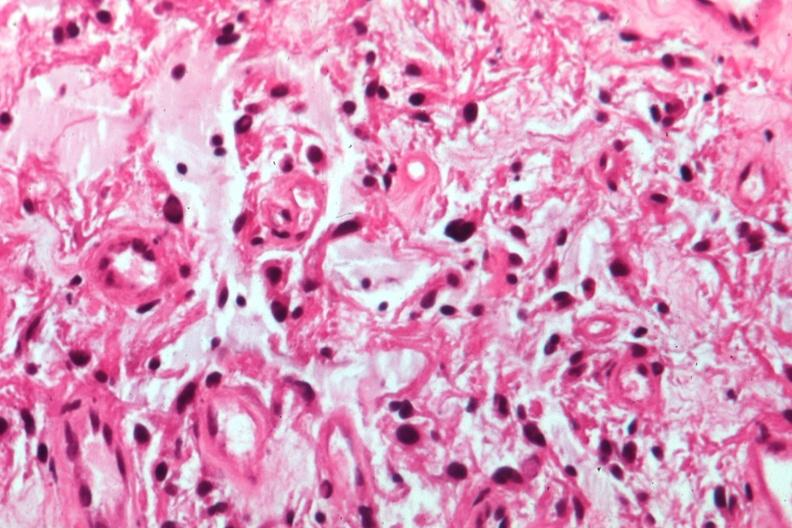what does this image show?
Answer the question using a single word or phrase. Glioma 